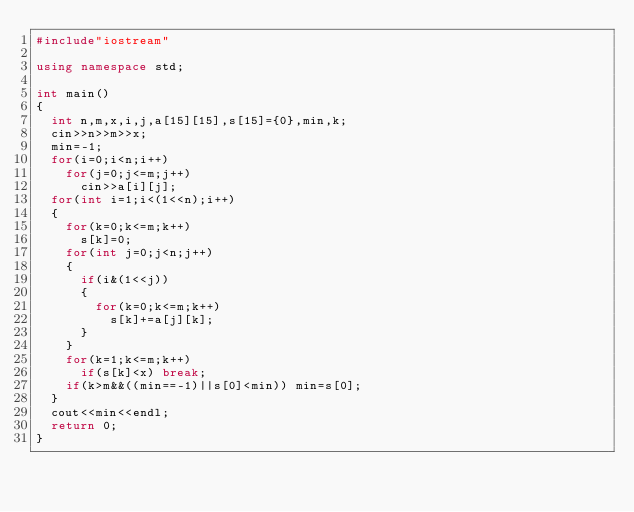Convert code to text. <code><loc_0><loc_0><loc_500><loc_500><_C++_>#include"iostream"

using namespace std;

int main()
{
	int n,m,x,i,j,a[15][15],s[15]={0},min,k;
	cin>>n>>m>>x;
	min=-1;
	for(i=0;i<n;i++)
		for(j=0;j<=m;j++)
			cin>>a[i][j];
	for(int i=1;i<(1<<n);i++)
	{
		for(k=0;k<=m;k++)
			s[k]=0;
		for(int j=0;j<n;j++)
		{
			if(i&(1<<j))
			{	
				for(k=0;k<=m;k++)
					s[k]+=a[j][k];
			}
		}
		for(k=1;k<=m;k++)
			if(s[k]<x) break;
		if(k>m&&((min==-1)||s[0]<min)) min=s[0];
	}
	cout<<min<<endl;
	return 0;
}
</code> 